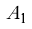Convert formula to latex. <formula><loc_0><loc_0><loc_500><loc_500>\tilde { A } _ { 1 }</formula> 